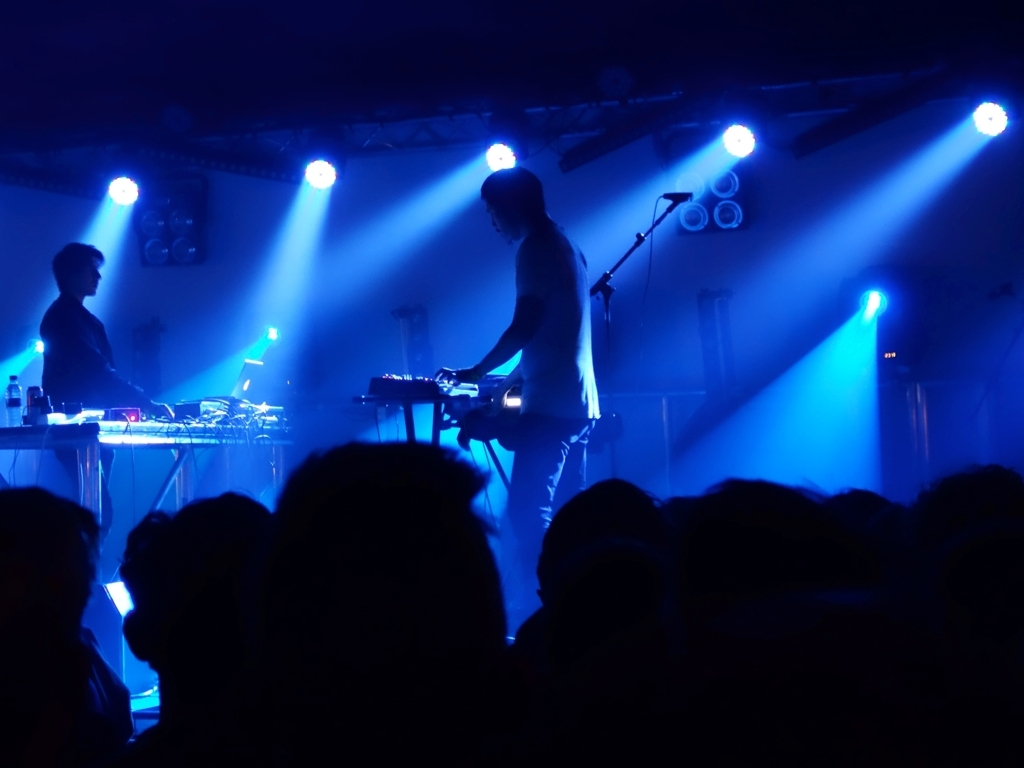What kind of event is depicted in the image? The image captures a concert scene, characterized by the stage lights, musicians with electronic equipment, and the silhouettes of an audience. 